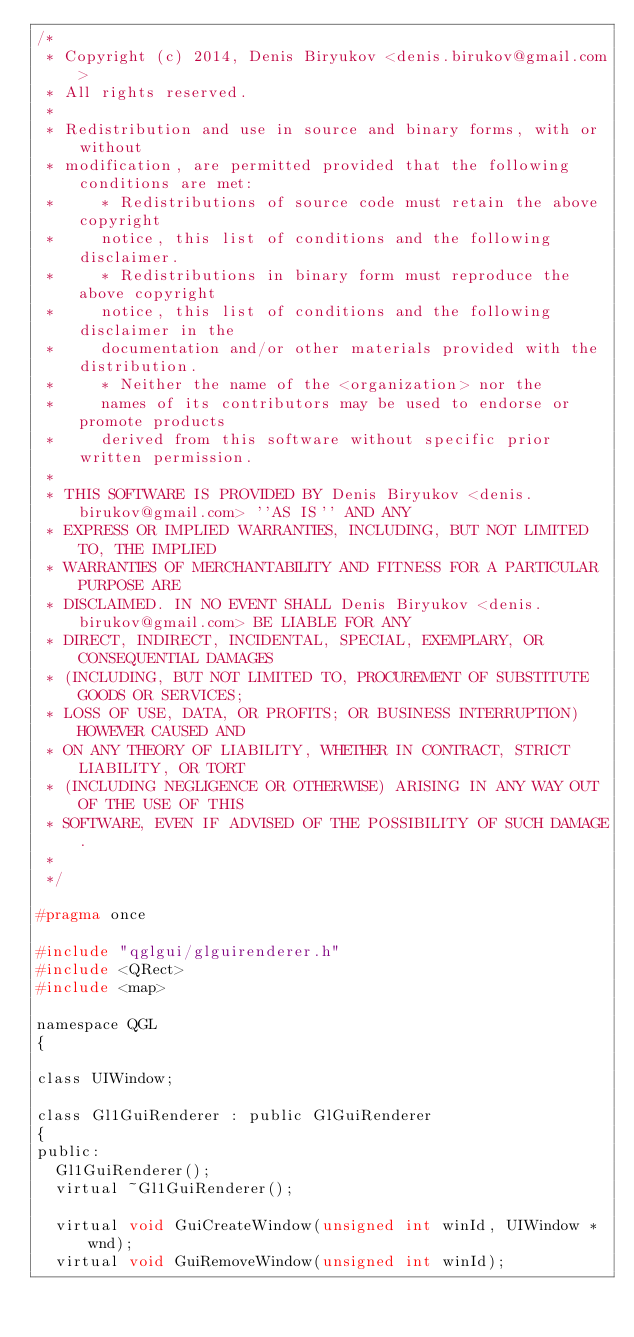Convert code to text. <code><loc_0><loc_0><loc_500><loc_500><_C_>/*
 * Copyright (c) 2014, Denis Biryukov <denis.birukov@gmail.com>
 * All rights reserved.
 *
 * Redistribution and use in source and binary forms, with or without
 * modification, are permitted provided that the following conditions are met:
 *     * Redistributions of source code must retain the above copyright
 *     notice, this list of conditions and the following disclaimer.
 *     * Redistributions in binary form must reproduce the above copyright
 *     notice, this list of conditions and the following disclaimer in the
 *     documentation and/or other materials provided with the distribution.
 *     * Neither the name of the <organization> nor the
 *     names of its contributors may be used to endorse or promote products
 *     derived from this software without specific prior written permission.
 *
 * THIS SOFTWARE IS PROVIDED BY Denis Biryukov <denis.birukov@gmail.com> ''AS IS'' AND ANY
 * EXPRESS OR IMPLIED WARRANTIES, INCLUDING, BUT NOT LIMITED TO, THE IMPLIED
 * WARRANTIES OF MERCHANTABILITY AND FITNESS FOR A PARTICULAR PURPOSE ARE
 * DISCLAIMED. IN NO EVENT SHALL Denis Biryukov <denis.birukov@gmail.com> BE LIABLE FOR ANY
 * DIRECT, INDIRECT, INCIDENTAL, SPECIAL, EXEMPLARY, OR CONSEQUENTIAL DAMAGES
 * (INCLUDING, BUT NOT LIMITED TO, PROCUREMENT OF SUBSTITUTE GOODS OR SERVICES;
 * LOSS OF USE, DATA, OR PROFITS; OR BUSINESS INTERRUPTION) HOWEVER CAUSED AND
 * ON ANY THEORY OF LIABILITY, WHETHER IN CONTRACT, STRICT LIABILITY, OR TORT
 * (INCLUDING NEGLIGENCE OR OTHERWISE) ARISING IN ANY WAY OUT OF THE USE OF THIS
 * SOFTWARE, EVEN IF ADVISED OF THE POSSIBILITY OF SUCH DAMAGE.
 *
 */

#pragma once

#include "qglgui/glguirenderer.h"
#include <QRect>
#include <map>

namespace QGL
{

class UIWindow;

class Gl1GuiRenderer : public GlGuiRenderer
{
public:
	Gl1GuiRenderer();
	virtual ~Gl1GuiRenderer();

	virtual void GuiCreateWindow(unsigned int winId, UIWindow *wnd);
	virtual void GuiRemoveWindow(unsigned int winId);</code> 